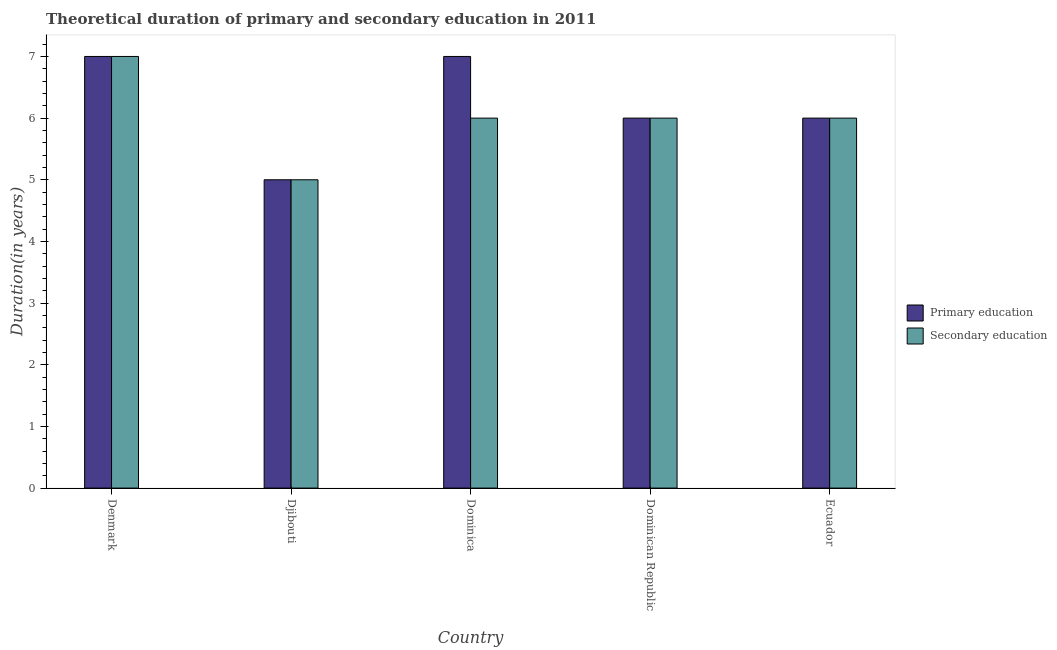How many different coloured bars are there?
Your answer should be very brief. 2. How many bars are there on the 5th tick from the right?
Ensure brevity in your answer.  2. In how many cases, is the number of bars for a given country not equal to the number of legend labels?
Your response must be concise. 0. What is the duration of primary education in Ecuador?
Keep it short and to the point. 6. Across all countries, what is the maximum duration of secondary education?
Give a very brief answer. 7. Across all countries, what is the minimum duration of primary education?
Your answer should be compact. 5. In which country was the duration of secondary education minimum?
Your response must be concise. Djibouti. What is the total duration of secondary education in the graph?
Ensure brevity in your answer.  30. What is the difference between the duration of secondary education in Djibouti and that in Dominican Republic?
Offer a very short reply. -1. What is the difference between the duration of secondary education in Denmark and the duration of primary education in Dominica?
Give a very brief answer. 0. In how many countries, is the duration of primary education greater than 3.2 years?
Keep it short and to the point. 5. Is the duration of secondary education in Djibouti less than that in Ecuador?
Your answer should be compact. Yes. Is the difference between the duration of primary education in Dominica and Dominican Republic greater than the difference between the duration of secondary education in Dominica and Dominican Republic?
Provide a short and direct response. Yes. What is the difference between the highest and the lowest duration of secondary education?
Provide a short and direct response. 2. In how many countries, is the duration of primary education greater than the average duration of primary education taken over all countries?
Offer a very short reply. 2. What does the 1st bar from the right in Dominica represents?
Your answer should be compact. Secondary education. Are all the bars in the graph horizontal?
Keep it short and to the point. No. What is the difference between two consecutive major ticks on the Y-axis?
Offer a very short reply. 1. Are the values on the major ticks of Y-axis written in scientific E-notation?
Offer a very short reply. No. Does the graph contain any zero values?
Ensure brevity in your answer.  No. How are the legend labels stacked?
Provide a short and direct response. Vertical. What is the title of the graph?
Your answer should be compact. Theoretical duration of primary and secondary education in 2011. What is the label or title of the Y-axis?
Make the answer very short. Duration(in years). What is the Duration(in years) in Primary education in Denmark?
Your answer should be compact. 7. What is the Duration(in years) of Secondary education in Djibouti?
Provide a succinct answer. 5. What is the Duration(in years) of Primary education in Dominica?
Your answer should be very brief. 7. What is the Duration(in years) of Secondary education in Dominica?
Offer a very short reply. 6. What is the Duration(in years) in Secondary education in Dominican Republic?
Keep it short and to the point. 6. What is the Duration(in years) in Primary education in Ecuador?
Give a very brief answer. 6. What is the Duration(in years) of Secondary education in Ecuador?
Make the answer very short. 6. Across all countries, what is the maximum Duration(in years) of Primary education?
Make the answer very short. 7. Across all countries, what is the maximum Duration(in years) of Secondary education?
Provide a short and direct response. 7. Across all countries, what is the minimum Duration(in years) in Primary education?
Provide a short and direct response. 5. Across all countries, what is the minimum Duration(in years) of Secondary education?
Ensure brevity in your answer.  5. What is the total Duration(in years) of Primary education in the graph?
Your answer should be compact. 31. What is the total Duration(in years) of Secondary education in the graph?
Your answer should be very brief. 30. What is the difference between the Duration(in years) in Primary education in Denmark and that in Djibouti?
Provide a succinct answer. 2. What is the difference between the Duration(in years) in Secondary education in Denmark and that in Djibouti?
Make the answer very short. 2. What is the difference between the Duration(in years) in Primary education in Denmark and that in Dominica?
Keep it short and to the point. 0. What is the difference between the Duration(in years) of Primary education in Denmark and that in Dominican Republic?
Give a very brief answer. 1. What is the difference between the Duration(in years) of Secondary education in Denmark and that in Dominican Republic?
Offer a terse response. 1. What is the difference between the Duration(in years) in Primary education in Denmark and that in Ecuador?
Provide a short and direct response. 1. What is the difference between the Duration(in years) of Primary education in Djibouti and that in Dominica?
Your answer should be very brief. -2. What is the difference between the Duration(in years) of Primary education in Djibouti and that in Dominican Republic?
Make the answer very short. -1. What is the difference between the Duration(in years) of Secondary education in Djibouti and that in Dominican Republic?
Keep it short and to the point. -1. What is the difference between the Duration(in years) in Primary education in Djibouti and that in Ecuador?
Offer a terse response. -1. What is the difference between the Duration(in years) of Secondary education in Djibouti and that in Ecuador?
Offer a terse response. -1. What is the difference between the Duration(in years) of Primary education in Dominica and that in Dominican Republic?
Keep it short and to the point. 1. What is the difference between the Duration(in years) in Secondary education in Dominica and that in Dominican Republic?
Keep it short and to the point. 0. What is the difference between the Duration(in years) in Secondary education in Dominica and that in Ecuador?
Ensure brevity in your answer.  0. What is the difference between the Duration(in years) in Primary education in Dominican Republic and that in Ecuador?
Make the answer very short. 0. What is the difference between the Duration(in years) in Secondary education in Dominican Republic and that in Ecuador?
Provide a short and direct response. 0. What is the difference between the Duration(in years) of Primary education in Denmark and the Duration(in years) of Secondary education in Djibouti?
Your response must be concise. 2. What is the difference between the Duration(in years) of Primary education in Denmark and the Duration(in years) of Secondary education in Dominica?
Your response must be concise. 1. What is the difference between the Duration(in years) of Primary education in Denmark and the Duration(in years) of Secondary education in Dominican Republic?
Provide a succinct answer. 1. What is the difference between the Duration(in years) of Primary education in Denmark and the Duration(in years) of Secondary education in Ecuador?
Offer a very short reply. 1. What is the difference between the Duration(in years) of Primary education in Djibouti and the Duration(in years) of Secondary education in Ecuador?
Ensure brevity in your answer.  -1. What is the average Duration(in years) in Primary education per country?
Your answer should be compact. 6.2. What is the average Duration(in years) in Secondary education per country?
Your answer should be compact. 6. What is the difference between the Duration(in years) in Primary education and Duration(in years) in Secondary education in Denmark?
Make the answer very short. 0. What is the difference between the Duration(in years) of Primary education and Duration(in years) of Secondary education in Ecuador?
Your answer should be compact. 0. What is the ratio of the Duration(in years) of Primary education in Denmark to that in Djibouti?
Give a very brief answer. 1.4. What is the ratio of the Duration(in years) of Secondary education in Denmark to that in Djibouti?
Give a very brief answer. 1.4. What is the ratio of the Duration(in years) of Secondary education in Denmark to that in Ecuador?
Keep it short and to the point. 1.17. What is the ratio of the Duration(in years) in Primary education in Djibouti to that in Dominica?
Make the answer very short. 0.71. What is the ratio of the Duration(in years) of Secondary education in Djibouti to that in Dominica?
Offer a very short reply. 0.83. What is the ratio of the Duration(in years) in Primary education in Djibouti to that in Dominican Republic?
Offer a very short reply. 0.83. What is the ratio of the Duration(in years) of Secondary education in Djibouti to that in Dominican Republic?
Provide a short and direct response. 0.83. What is the ratio of the Duration(in years) in Primary education in Dominica to that in Dominican Republic?
Make the answer very short. 1.17. What is the ratio of the Duration(in years) of Secondary education in Dominica to that in Dominican Republic?
Give a very brief answer. 1. What is the ratio of the Duration(in years) in Primary education in Dominican Republic to that in Ecuador?
Offer a terse response. 1. What is the difference between the highest and the second highest Duration(in years) of Primary education?
Ensure brevity in your answer.  0. What is the difference between the highest and the lowest Duration(in years) in Secondary education?
Your answer should be very brief. 2. 